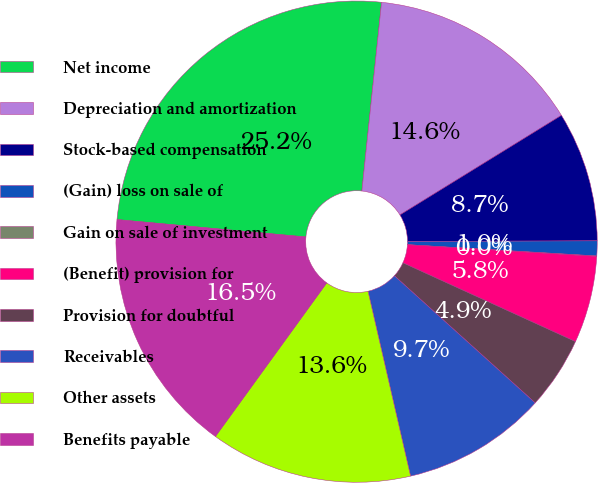Convert chart. <chart><loc_0><loc_0><loc_500><loc_500><pie_chart><fcel>Net income<fcel>Depreciation and amortization<fcel>Stock-based compensation<fcel>(Gain) loss on sale of<fcel>Gain on sale of investment<fcel>(Benefit) provision for<fcel>Provision for doubtful<fcel>Receivables<fcel>Other assets<fcel>Benefits payable<nl><fcel>25.19%<fcel>14.55%<fcel>8.74%<fcel>1.0%<fcel>0.03%<fcel>5.84%<fcel>4.87%<fcel>9.71%<fcel>13.58%<fcel>16.48%<nl></chart> 